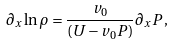<formula> <loc_0><loc_0><loc_500><loc_500>\partial _ { x } \ln \rho = \frac { v _ { 0 } } { \left ( U - v _ { 0 } P \right ) } \partial _ { x } P \, ,</formula> 